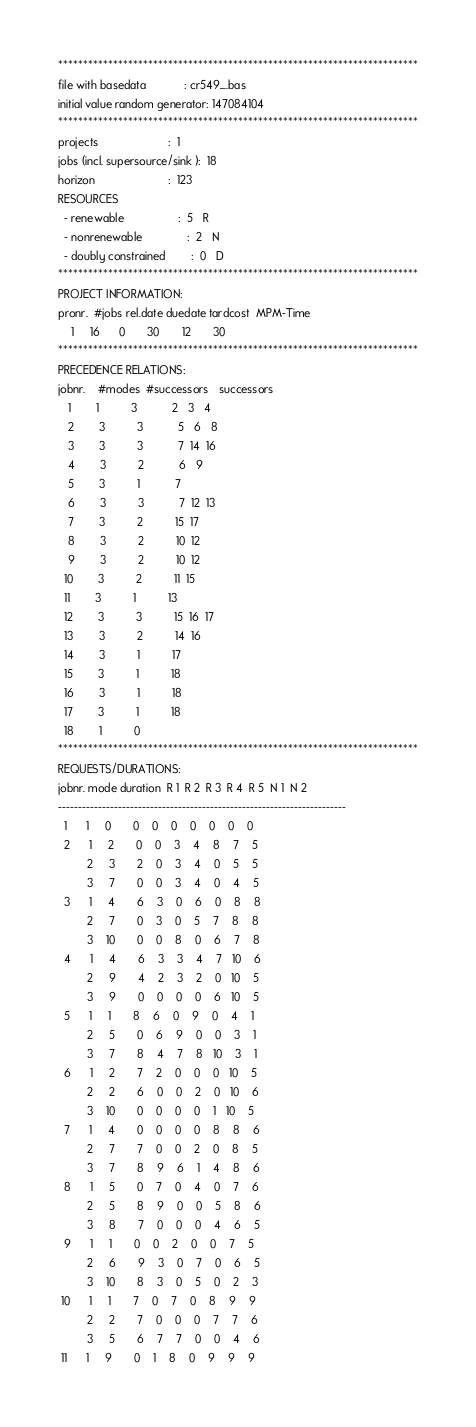<code> <loc_0><loc_0><loc_500><loc_500><_ObjectiveC_>************************************************************************
file with basedata            : cr549_.bas
initial value random generator: 147084104
************************************************************************
projects                      :  1
jobs (incl. supersource/sink ):  18
horizon                       :  123
RESOURCES
  - renewable                 :  5   R
  - nonrenewable              :  2   N
  - doubly constrained        :  0   D
************************************************************************
PROJECT INFORMATION:
pronr.  #jobs rel.date duedate tardcost  MPM-Time
    1     16      0       30       12       30
************************************************************************
PRECEDENCE RELATIONS:
jobnr.    #modes  #successors   successors
   1        1          3           2   3   4
   2        3          3           5   6   8
   3        3          3           7  14  16
   4        3          2           6   9
   5        3          1           7
   6        3          3           7  12  13
   7        3          2          15  17
   8        3          2          10  12
   9        3          2          10  12
  10        3          2          11  15
  11        3          1          13
  12        3          3          15  16  17
  13        3          2          14  16
  14        3          1          17
  15        3          1          18
  16        3          1          18
  17        3          1          18
  18        1          0        
************************************************************************
REQUESTS/DURATIONS:
jobnr. mode duration  R 1  R 2  R 3  R 4  R 5  N 1  N 2
------------------------------------------------------------------------
  1      1     0       0    0    0    0    0    0    0
  2      1     2       0    0    3    4    8    7    5
         2     3       2    0    3    4    0    5    5
         3     7       0    0    3    4    0    4    5
  3      1     4       6    3    0    6    0    8    8
         2     7       0    3    0    5    7    8    8
         3    10       0    0    8    0    6    7    8
  4      1     4       6    3    3    4    7   10    6
         2     9       4    2    3    2    0   10    5
         3     9       0    0    0    0    6   10    5
  5      1     1       8    6    0    9    0    4    1
         2     5       0    6    9    0    0    3    1
         3     7       8    4    7    8   10    3    1
  6      1     2       7    2    0    0    0   10    5
         2     2       6    0    0    2    0   10    6
         3    10       0    0    0    0    1   10    5
  7      1     4       0    0    0    0    8    8    6
         2     7       7    0    0    2    0    8    5
         3     7       8    9    6    1    4    8    6
  8      1     5       0    7    0    4    0    7    6
         2     5       8    9    0    0    5    8    6
         3     8       7    0    0    0    4    6    5
  9      1     1       0    0    2    0    0    7    5
         2     6       9    3    0    7    0    6    5
         3    10       8    3    0    5    0    2    3
 10      1     1       7    0    7    0    8    9    9
         2     2       7    0    0    0    7    7    6
         3     5       6    7    7    0    0    4    6
 11      1     9       0    1    8    0    9    9    9</code> 